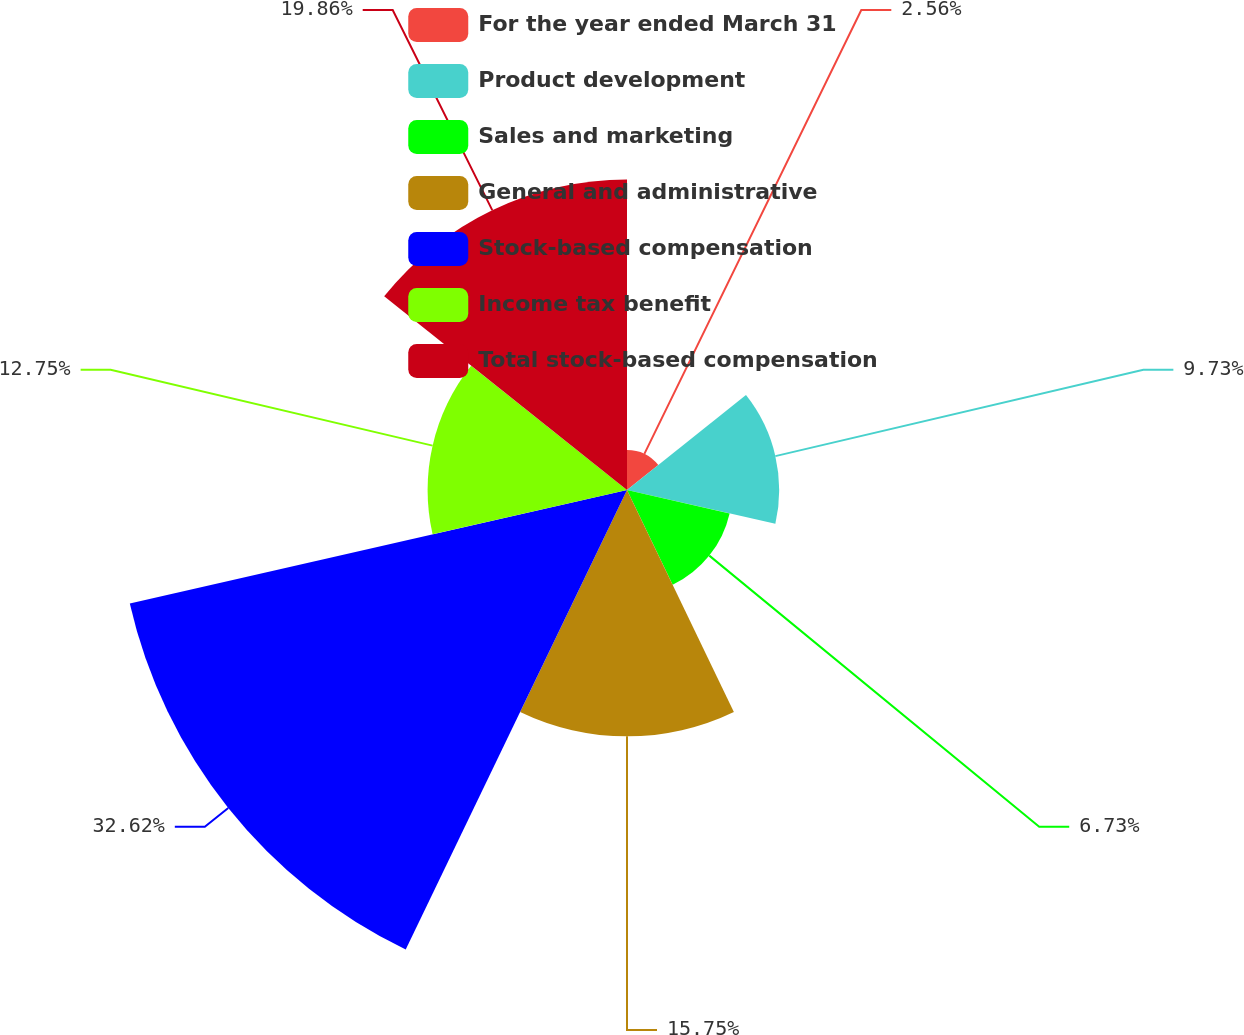Convert chart. <chart><loc_0><loc_0><loc_500><loc_500><pie_chart><fcel>For the year ended March 31<fcel>Product development<fcel>Sales and marketing<fcel>General and administrative<fcel>Stock-based compensation<fcel>Income tax benefit<fcel>Total stock-based compensation<nl><fcel>2.56%<fcel>9.73%<fcel>6.73%<fcel>15.75%<fcel>32.61%<fcel>12.75%<fcel>19.86%<nl></chart> 